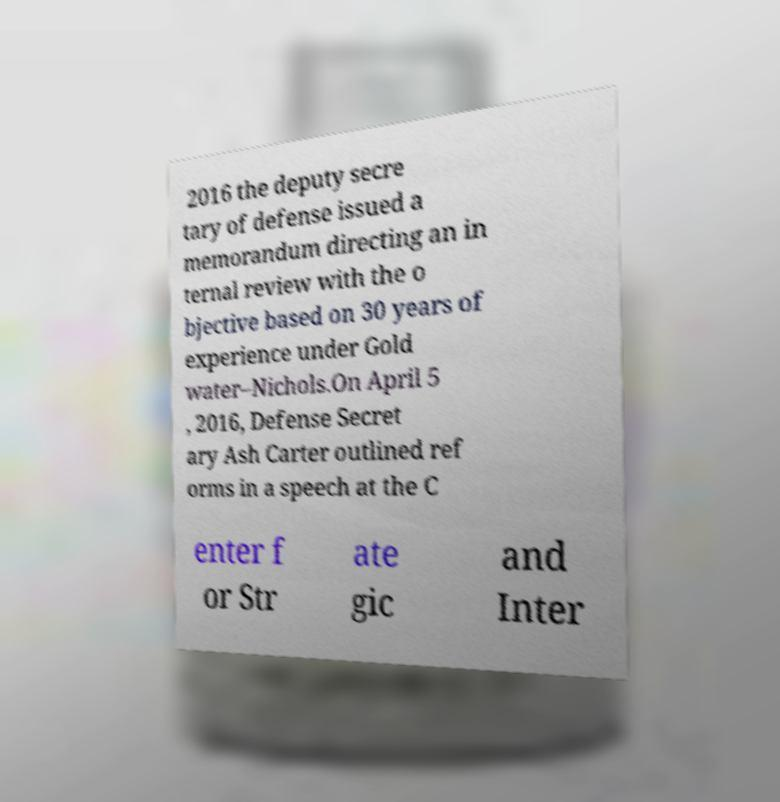Please identify and transcribe the text found in this image. 2016 the deputy secre tary of defense issued a memorandum directing an in ternal review with the o bjective based on 30 years of experience under Gold water–Nichols.On April 5 , 2016, Defense Secret ary Ash Carter outlined ref orms in a speech at the C enter f or Str ate gic and Inter 